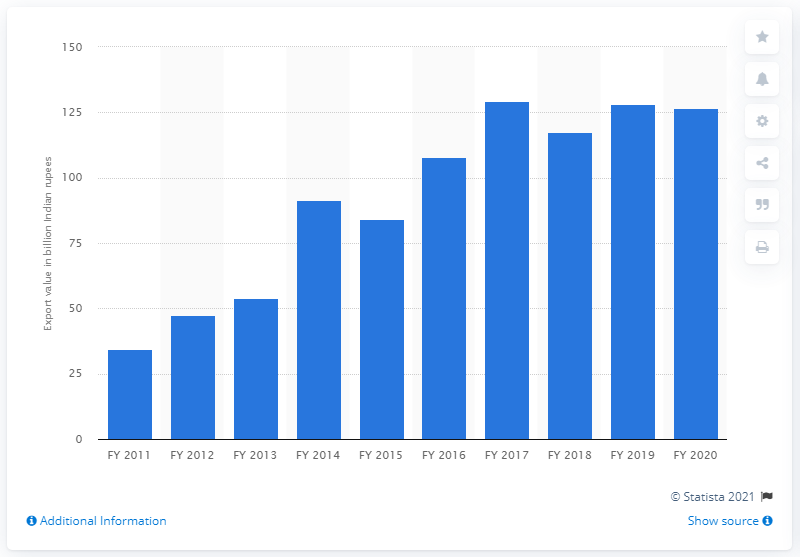Mention a couple of crucial points in this snapshot. In the fiscal year 2020, India exported handicrafts worth 126.57 million Indian rupees. In the fiscal year 2020, India exported a total of 128.35 handicrafts. 